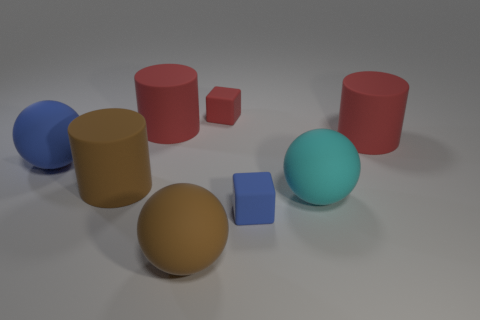Is the number of brown matte things greater than the number of blue blocks?
Provide a succinct answer. Yes. Are there any tiny cyan things that have the same shape as the tiny red thing?
Offer a terse response. No. The cyan rubber thing in front of the big blue ball has what shape?
Your answer should be compact. Sphere. There is a cylinder that is to the right of the large brown object in front of the brown rubber cylinder; what number of large brown cylinders are in front of it?
Ensure brevity in your answer.  1. What number of other things are the same shape as the big blue rubber object?
Your answer should be very brief. 2. How many other things are there of the same material as the brown cylinder?
Keep it short and to the point. 7. What material is the large cylinder that is in front of the big matte sphere that is on the left side of the big brown object that is behind the brown ball?
Your answer should be compact. Rubber. Is the material of the large cyan object the same as the brown cylinder?
Provide a succinct answer. Yes. How many cylinders are either matte objects or big cyan rubber objects?
Your response must be concise. 3. What is the color of the sphere that is to the right of the brown matte sphere?
Keep it short and to the point. Cyan. 